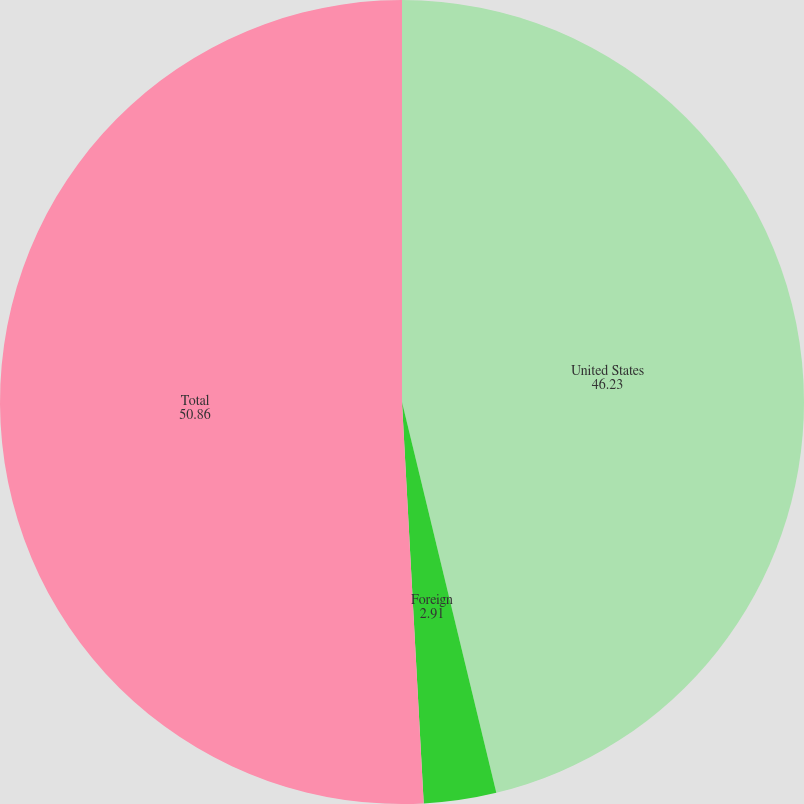Convert chart. <chart><loc_0><loc_0><loc_500><loc_500><pie_chart><fcel>United States<fcel>Foreign<fcel>Total<nl><fcel>46.23%<fcel>2.91%<fcel>50.86%<nl></chart> 